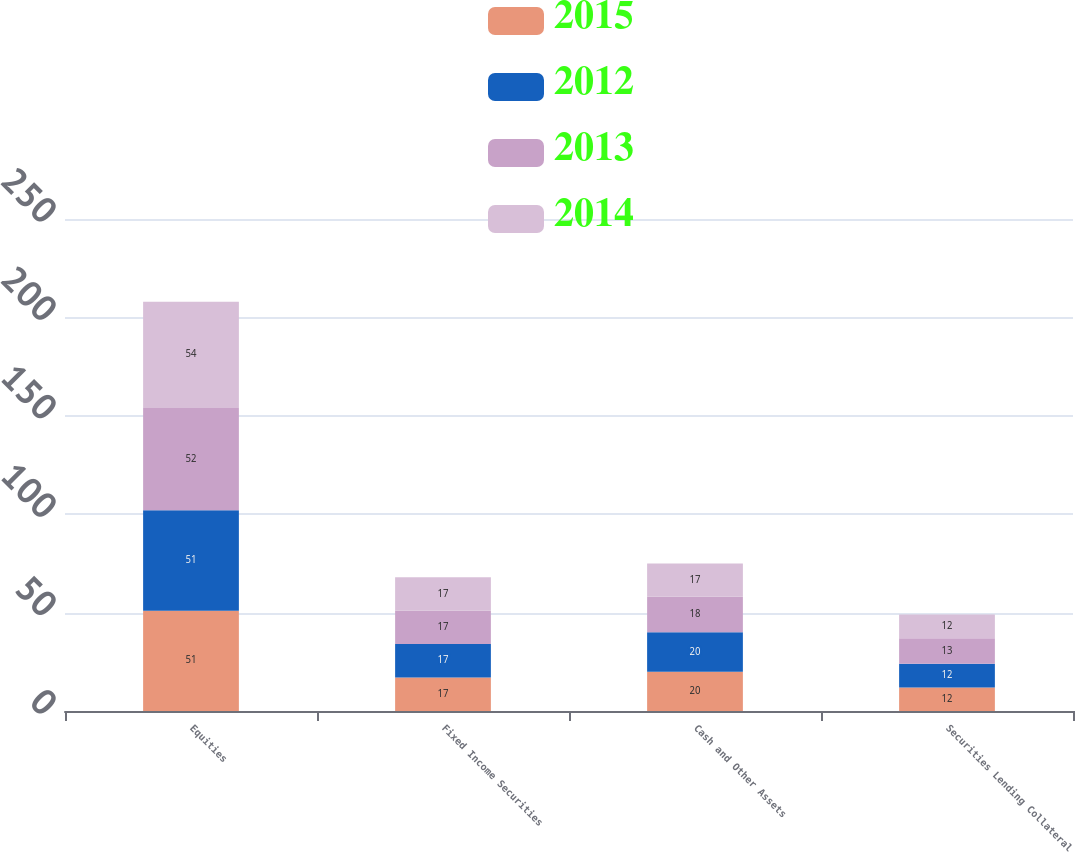<chart> <loc_0><loc_0><loc_500><loc_500><stacked_bar_chart><ecel><fcel>Equities<fcel>Fixed Income Securities<fcel>Cash and Other Assets<fcel>Securities Lending Collateral<nl><fcel>2015<fcel>51<fcel>17<fcel>20<fcel>12<nl><fcel>2012<fcel>51<fcel>17<fcel>20<fcel>12<nl><fcel>2013<fcel>52<fcel>17<fcel>18<fcel>13<nl><fcel>2014<fcel>54<fcel>17<fcel>17<fcel>12<nl></chart> 